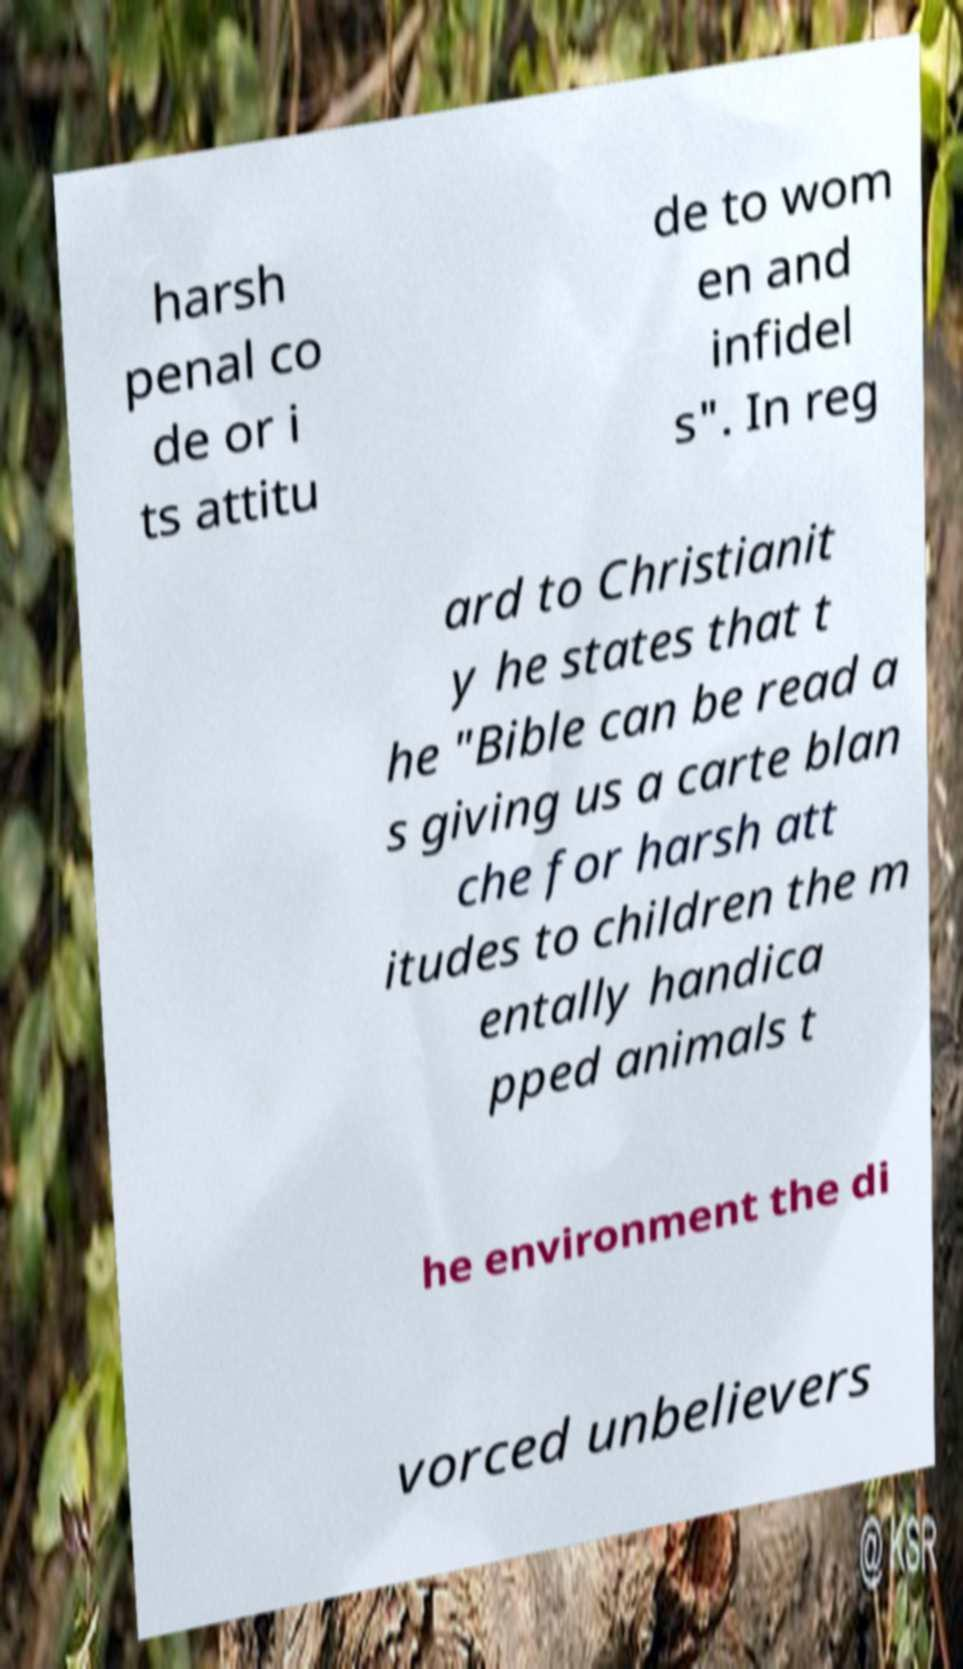For documentation purposes, I need the text within this image transcribed. Could you provide that? harsh penal co de or i ts attitu de to wom en and infidel s". In reg ard to Christianit y he states that t he "Bible can be read a s giving us a carte blan che for harsh att itudes to children the m entally handica pped animals t he environment the di vorced unbelievers 